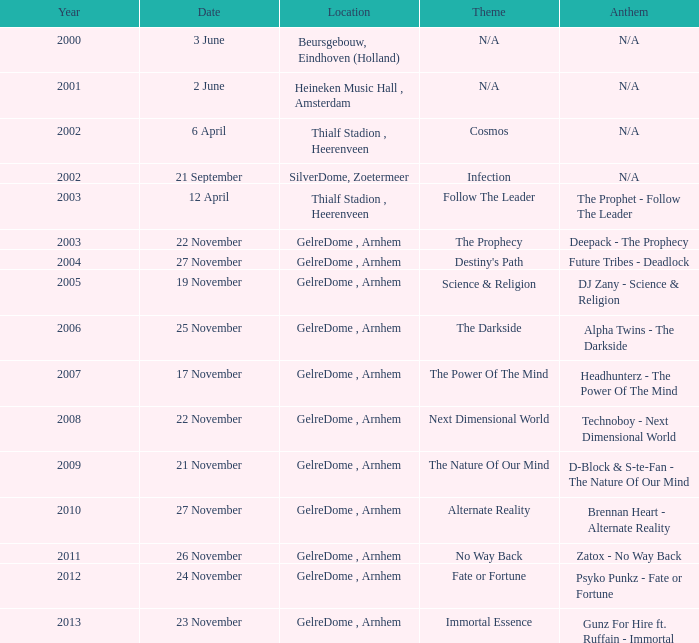What is the location in 2007? GelreDome , Arnhem. 